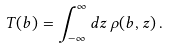Convert formula to latex. <formula><loc_0><loc_0><loc_500><loc_500>T ( b ) = \int _ { - \infty } ^ { \infty } d z \, \rho ( b , z ) \, .</formula> 